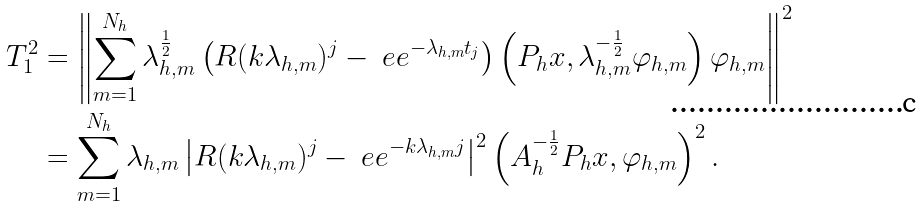Convert formula to latex. <formula><loc_0><loc_0><loc_500><loc_500>T _ { 1 } ^ { 2 } & = \left \| \sum _ { m = 1 } ^ { N _ { h } } \lambda _ { h , m } ^ { \frac { 1 } { 2 } } \left ( R ( k \lambda _ { h , m } ) ^ { j } - \ e e ^ { - \lambda _ { h , m } t _ { j } } \right ) \left ( P _ { h } x , \lambda _ { h , m } ^ { - \frac { 1 } { 2 } } \varphi _ { h , m } \right ) \varphi _ { h , m } \right \| ^ { 2 } \\ & = \sum _ { m = 1 } ^ { N _ { h } } \lambda _ { h , m } \left | R ( k \lambda _ { h , m } ) ^ { j } - \ e e ^ { - k \lambda _ { h , m } j } \right | ^ { 2 } \left ( A _ { h } ^ { - \frac { 1 } { 2 } } P _ { h } x , \varphi _ { h , m } \right ) ^ { 2 } .</formula> 